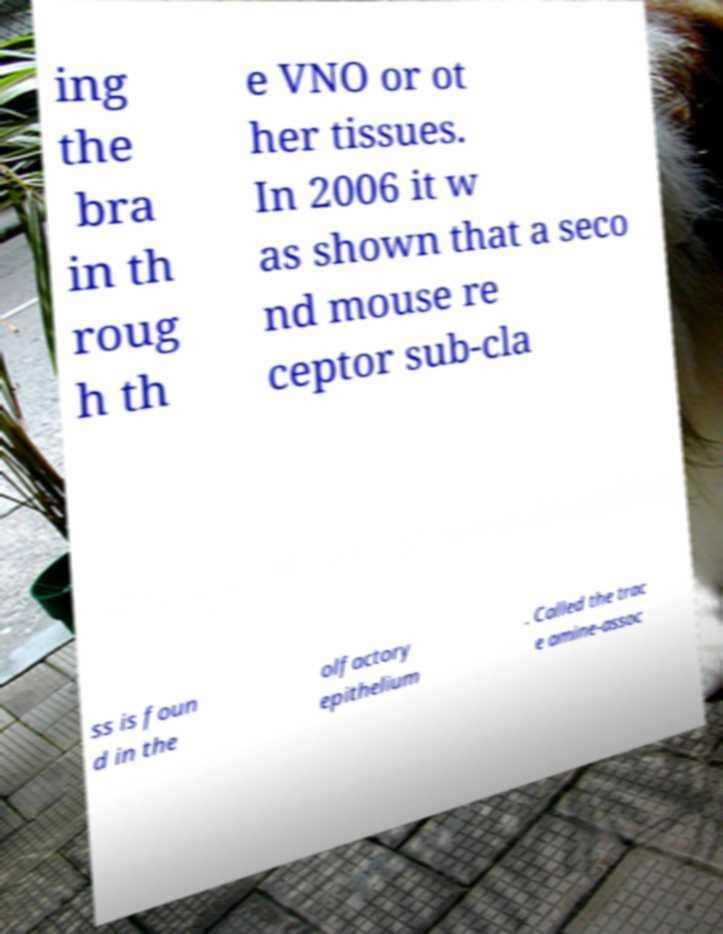Could you extract and type out the text from this image? ing the bra in th roug h th e VNO or ot her tissues. In 2006 it w as shown that a seco nd mouse re ceptor sub-cla ss is foun d in the olfactory epithelium . Called the trac e amine-assoc 